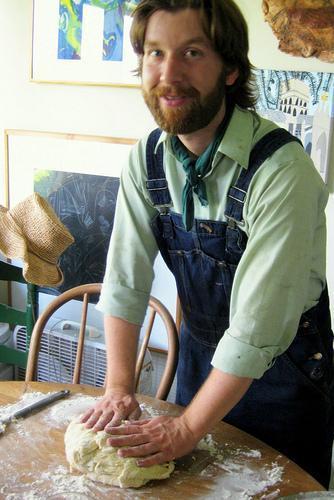How many people are there?
Give a very brief answer. 1. 